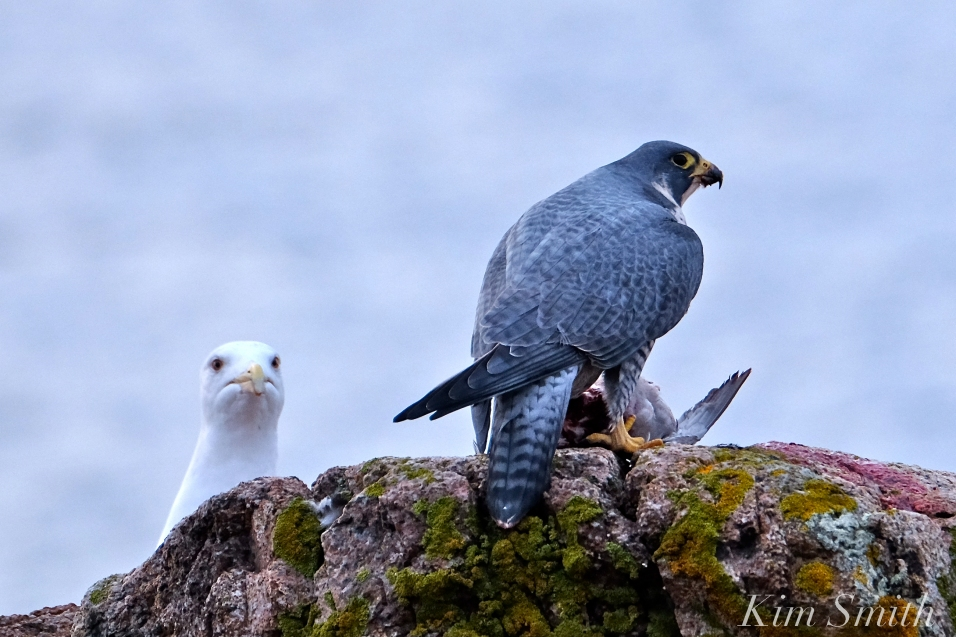Imagine if this Peregrine Falcon could speak, what might it be thinking or saying in this situation? If the Peregrine Falcon could speak, it might be saying something like: 'This catch is mine, and I am ready to defend it at any cost. Stay back, intruder, or face my wrath.' The falcon's expression and body language convey a firm determination to protect its prey, and it is likely feeling a mix of satisfaction from the hunt and wariness at the potential threat posed by the observing gull. The falcon is in a vigilant state, ensuring that its hard-earned meal is not taken away.  If the gull could respond, what might it say? The gull might respond, 'I’m just watching from a safe distance, waiting for my chance. Maybe you’ll leave something behind that I can snatch without a fight. No need for conflict unless you make a move on me.' The gull is likely assessing the situation, aware of the falcon’s prowess but also ready to take advantage of any opportunity to access some of the prey. The gull’s cautious yet opportunistic nature comes through in this imagined dialogue. 